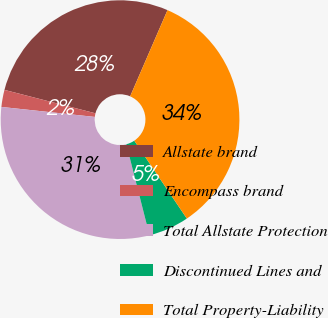Convert chart. <chart><loc_0><loc_0><loc_500><loc_500><pie_chart><fcel>Allstate brand<fcel>Encompass brand<fcel>Total Allstate Protection<fcel>Discontinued Lines and<fcel>Total Property-Liability<nl><fcel>27.5%<fcel>2.31%<fcel>30.67%<fcel>5.48%<fcel>34.04%<nl></chart> 